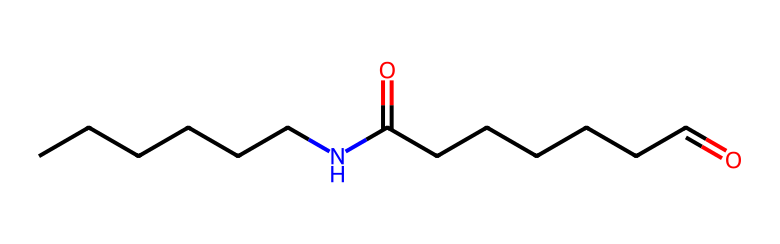What is the functional group present in this polymer? The structure includes a carbonyl group (C=O) with the nitrogen atom, signifying that this is an amide due to the nitrogen being directly bonded to the carbon of the carbonyl.
Answer: amide How many carbon atoms are in this polymer? Counting the carbon atoms in the structure, there are a total of 12 carbon atoms.
Answer: 12 What is the general name for the type of polymer represented? This chemical represents a type of polyamide, specifically nylon, due to its repeating amide linkages.
Answer: polyamide How many nitrogen atoms are in this structure? The structure contains one nitrogen atom, which is evident from the N in the SMILES representation.
Answer: 1 What type of interactions can nylon exhibit due to its molecular structure? Due to the presence of the amide functional group, nylon can engage in hydrogen bonding, leading to higher tensile strength and durability.
Answer: hydrogen bonding What is the main application of this chemical in sports equipment? Nylon is commonly used for making baseball nets and protective screens due to its strength and resilience.
Answer: nets and protective screens 